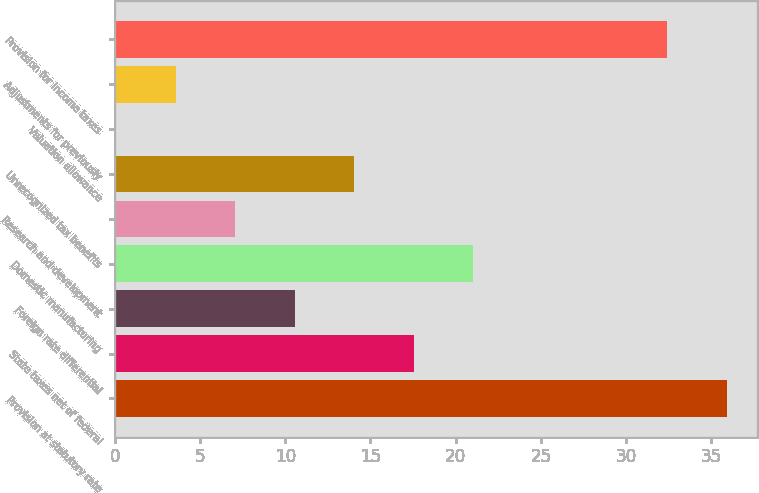<chart> <loc_0><loc_0><loc_500><loc_500><bar_chart><fcel>Provision at statutory rate<fcel>State taxes net of federal<fcel>Foreign rate differential<fcel>Domestic manufacturing<fcel>Research and development<fcel>Unrecognized tax benefits<fcel>Valuation allowance<fcel>Adjustments for previously<fcel>Provision for income taxes<nl><fcel>35.89<fcel>17.55<fcel>10.57<fcel>21.04<fcel>7.08<fcel>14.06<fcel>0.1<fcel>3.59<fcel>32.4<nl></chart> 